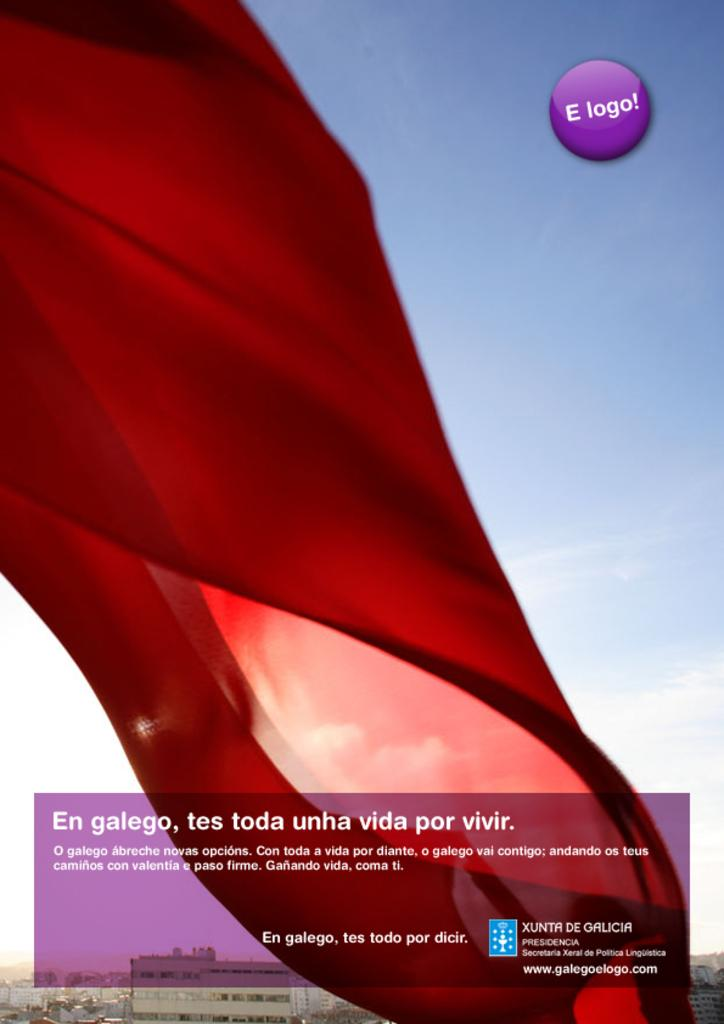<image>
Share a concise interpretation of the image provided. An image of red fabric in the wind with a website of www.galegoelogo.com in the lower right corner. 